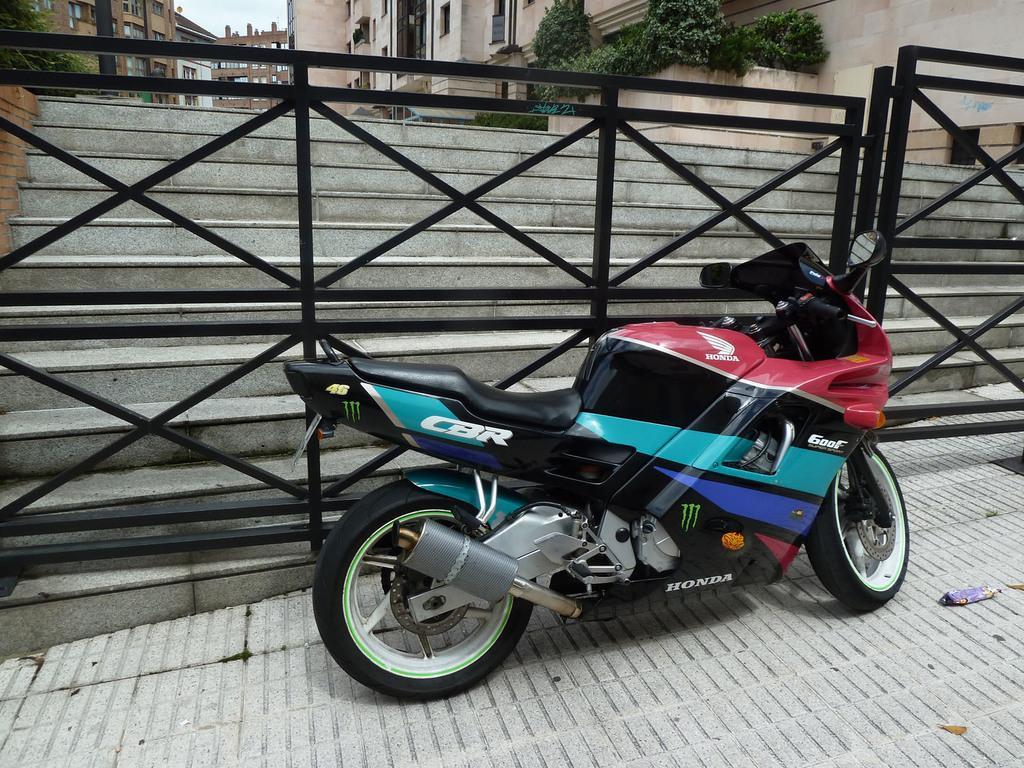How would you summarize this image in a sentence or two? There is a bike in red, black, blue, violet and gray color combination on the footpath, near a black color fencing and steps. In the background, there are plants, buildings which are having glass windows and there is sky. 